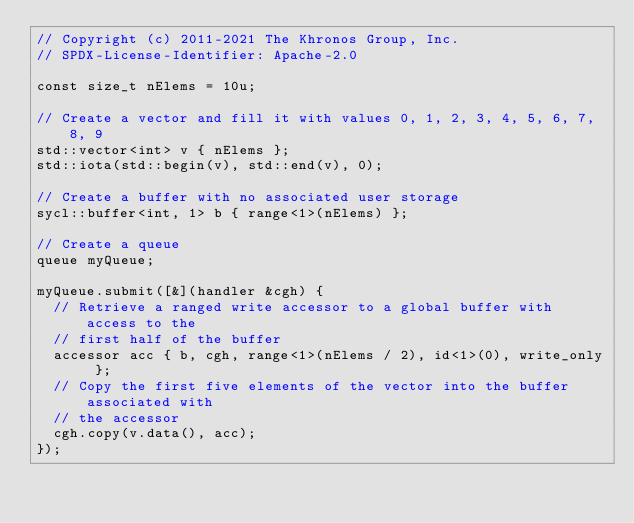Convert code to text. <code><loc_0><loc_0><loc_500><loc_500><_C++_>// Copyright (c) 2011-2021 The Khronos Group, Inc.
// SPDX-License-Identifier: Apache-2.0

const size_t nElems = 10u;

// Create a vector and fill it with values 0, 1, 2, 3, 4, 5, 6, 7, 8, 9
std::vector<int> v { nElems };
std::iota(std::begin(v), std::end(v), 0);

// Create a buffer with no associated user storage
sycl::buffer<int, 1> b { range<1>(nElems) };

// Create a queue
queue myQueue;

myQueue.submit([&](handler &cgh) {
  // Retrieve a ranged write accessor to a global buffer with access to the
  // first half of the buffer
  accessor acc { b, cgh, range<1>(nElems / 2), id<1>(0), write_only };
  // Copy the first five elements of the vector into the buffer associated with
  // the accessor
  cgh.copy(v.data(), acc);
});
</code> 